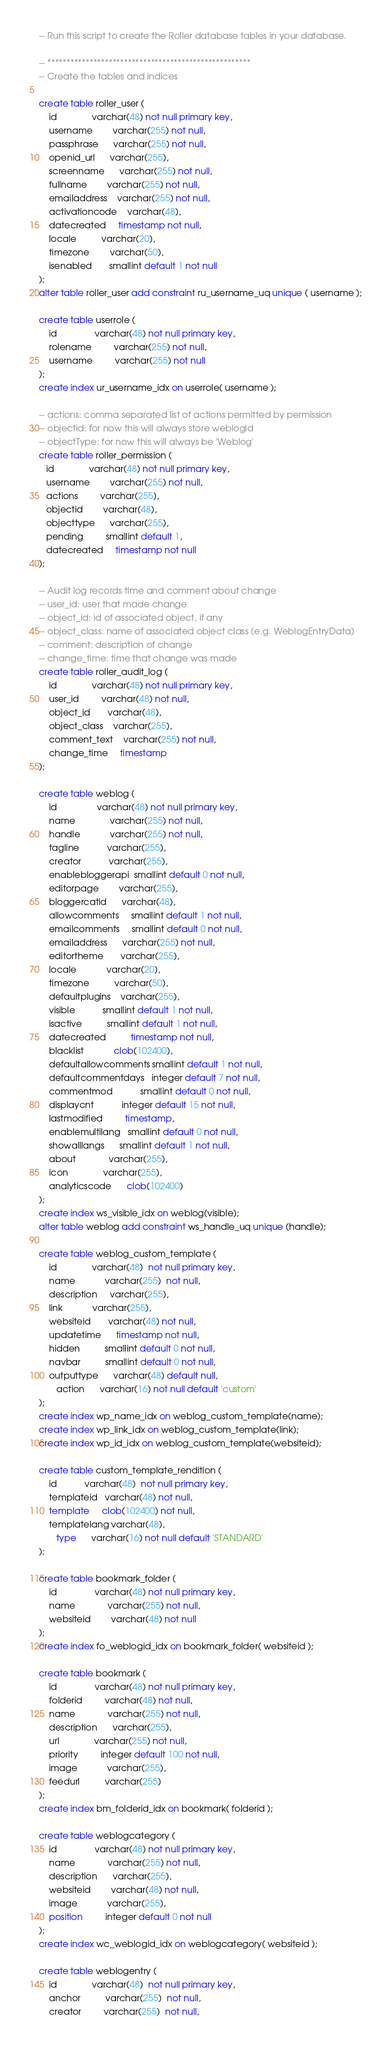Convert code to text. <code><loc_0><loc_0><loc_500><loc_500><_SQL_>

-- Run this script to create the Roller database tables in your database.

-- *****************************************************
-- Create the tables and indices

create table roller_user (
    id              varchar(48) not null primary key,
    username        varchar(255) not null,
    passphrase      varchar(255) not null,
    openid_url      varchar(255),
    screenname      varchar(255) not null,
    fullname        varchar(255) not null,
    emailaddress    varchar(255) not null,
    activationcode	varchar(48),
    datecreated     timestamp not null,
    locale          varchar(20),  
    timezone        varchar(50),    
    isenabled       smallint default 1 not null
);
alter table roller_user add constraint ru_username_uq unique ( username );

create table userrole (
    id               varchar(48) not null primary key,
    rolename         varchar(255) not null,
    username         varchar(255) not null
);
create index ur_username_idx on userrole( username );

-- actions: comma separated list of actions permitted by permission
-- objectid: for now this will always store weblogid
-- objectType: for now this will always be 'Weblog'
create table roller_permission (
   id              varchar(48) not null primary key,
   username        varchar(255) not null,
   actions         varchar(255), 
   objectid        varchar(48),           
   objecttype      varchar(255), 
   pending         smallint default 1,         
   datecreated     timestamp not null
);

-- Audit log records time and comment about change
-- user_id: user that made change
-- object_id: id of associated object, if any
-- object_class: name of associated object class (e.g. WeblogEntryData)
-- comment: description of change
-- change_time: time that change was made
create table roller_audit_log (
    id              varchar(48) not null primary key,
    user_id         varchar(48) not null,  
    object_id       varchar(48),           
    object_class    varchar(255),          
    comment_text    varchar(255) not null, 
    change_time     timestamp              
);

create table weblog (
    id                varchar(48) not null primary key,
    name              varchar(255) not null,
    handle            varchar(255) not null,
    tagline           varchar(255),
    creator           varchar(255),
    enablebloggerapi  smallint default 0 not null,
    editorpage        varchar(255),
    bloggercatid      varchar(48),
    allowcomments     smallint default 1 not null,
    emailcomments     smallint default 0 not null,
    emailaddress      varchar(255) not null,
    editortheme       varchar(255),
    locale            varchar(20),
    timezone          varchar(50),
    defaultplugins    varchar(255),
    visible           smallint default 1 not null,
    isactive          smallint default 1 not null,
    datecreated          timestamp not null,
    blacklist            clob(102400),
    defaultallowcomments smallint default 1 not null,
    defaultcommentdays   integer default 7 not null,
    commentmod           smallint default 0 not null,
    displaycnt           integer default 15 not null,
    lastmodified         timestamp,
    enablemultilang   smallint default 0 not null,
    showalllangs      smallint default 1 not null,
    about             varchar(255),
    icon              varchar(255),
    analyticscode      clob(102400)
);
create index ws_visible_idx on weblog(visible);
alter table weblog add constraint ws_handle_uq unique (handle);

create table weblog_custom_template (
    id              varchar(48)  not null primary key,
    name            varchar(255)  not null,
    description     varchar(255),
    link            varchar(255),
    websiteid       varchar(48) not null,
    updatetime      timestamp not null,
    hidden          smallint default 0 not null,
    navbar          smallint default 0 not null,
    outputtype      varchar(48) default null,
       action      varchar(16) not null default 'custom'
);
create index wp_name_idx on weblog_custom_template(name);
create index wp_link_idx on weblog_custom_template(link);
create index wp_id_idx on weblog_custom_template(websiteid);

create table custom_template_rendition (
    id           varchar(48)  not null primary key,
    templateid   varchar(48) not null,
    template     clob(102400) not null,
    templatelang varchar(48),
       type      varchar(16) not null default 'STANDARD'
);

create table bookmark_folder (
    id               varchar(48) not null primary key,
    name             varchar(255) not null,
    websiteid        varchar(48) not null
);
create index fo_weblogid_idx on bookmark_folder( websiteid );

create table bookmark (
    id               varchar(48) not null primary key,
    folderid         varchar(48) not null,
    name             varchar(255) not null,
    description      varchar(255),
    url              varchar(255) not null,
    priority         integer default 100 not null,
    image            varchar(255),
    feedurl          varchar(255)
);
create index bm_folderid_idx on bookmark( folderid );

create table weblogcategory (
    id               varchar(48) not null primary key,
    name             varchar(255) not null,
    description      varchar(255),
    websiteid        varchar(48) not null,
    image            varchar(255),
    position         integer default 0 not null
);
create index wc_weblogid_idx on weblogcategory( websiteid );

create table weblogentry (
    id              varchar(48)  not null primary key,
    anchor          varchar(255)  not null,
    creator         varchar(255)  not null,</code> 